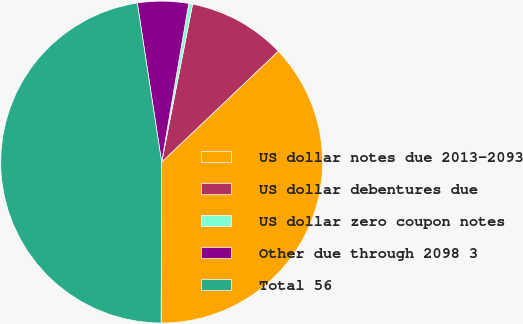Convert chart to OTSL. <chart><loc_0><loc_0><loc_500><loc_500><pie_chart><fcel>US dollar notes due 2013-2093<fcel>US dollar debentures due<fcel>US dollar zero coupon notes<fcel>Other due through 2098 3<fcel>Total 56<nl><fcel>37.15%<fcel>9.82%<fcel>0.39%<fcel>5.11%<fcel>47.53%<nl></chart> 